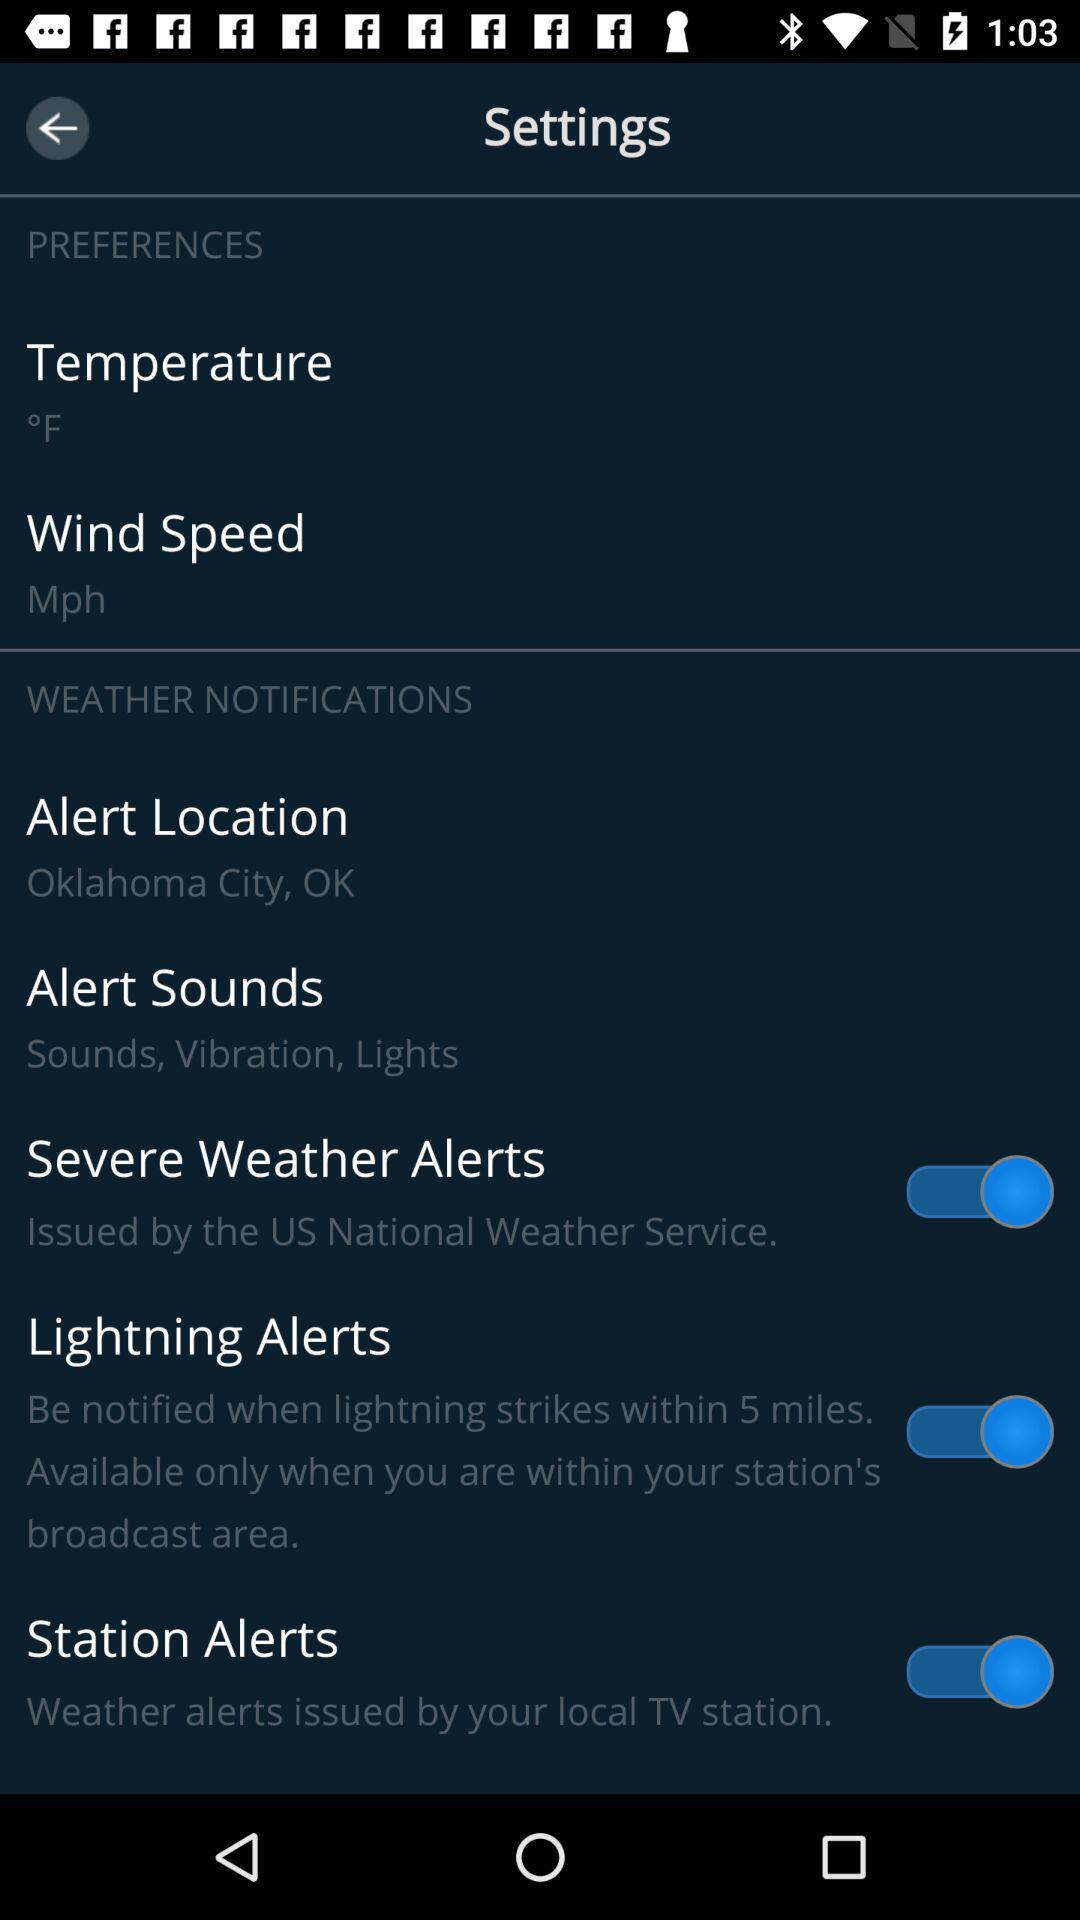How many more weather notifications are there than preferences?
Answer the question using a single word or phrase. 3 